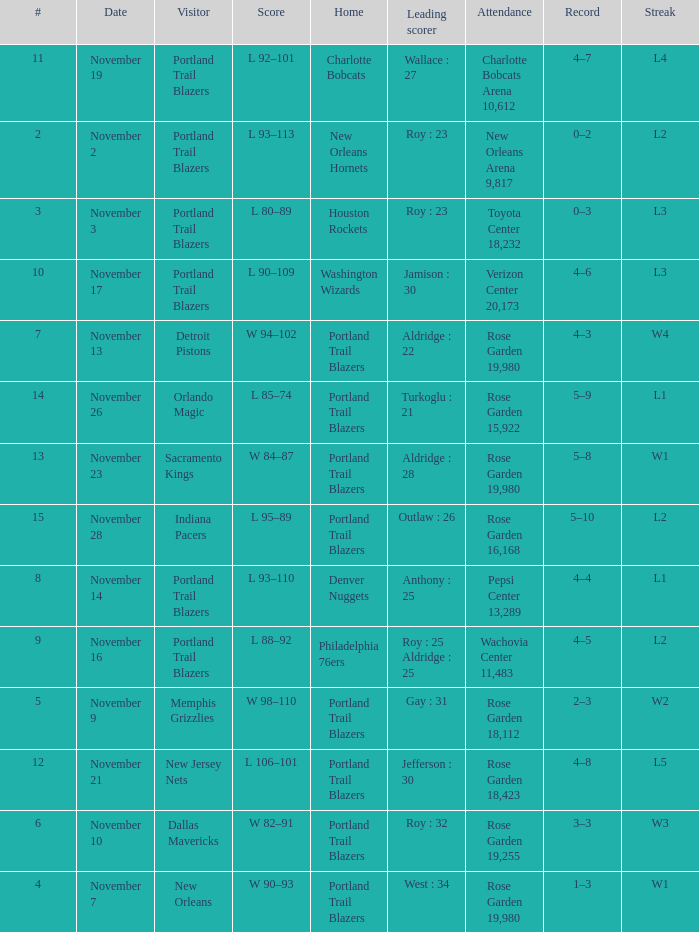 what's the attendance where score is l 92–101 Charlotte Bobcats Arena 10,612. Write the full table. {'header': ['#', 'Date', 'Visitor', 'Score', 'Home', 'Leading scorer', 'Attendance', 'Record', 'Streak'], 'rows': [['11', 'November 19', 'Portland Trail Blazers', 'L 92–101', 'Charlotte Bobcats', 'Wallace : 27', 'Charlotte Bobcats Arena 10,612', '4–7', 'L4'], ['2', 'November 2', 'Portland Trail Blazers', 'L 93–113', 'New Orleans Hornets', 'Roy : 23', 'New Orleans Arena 9,817', '0–2', 'L2'], ['3', 'November 3', 'Portland Trail Blazers', 'L 80–89', 'Houston Rockets', 'Roy : 23', 'Toyota Center 18,232', '0–3', 'L3'], ['10', 'November 17', 'Portland Trail Blazers', 'L 90–109', 'Washington Wizards', 'Jamison : 30', 'Verizon Center 20,173', '4–6', 'L3'], ['7', 'November 13', 'Detroit Pistons', 'W 94–102', 'Portland Trail Blazers', 'Aldridge : 22', 'Rose Garden 19,980', '4–3', 'W4'], ['14', 'November 26', 'Orlando Magic', 'L 85–74', 'Portland Trail Blazers', 'Turkoglu : 21', 'Rose Garden 15,922', '5–9', 'L1'], ['13', 'November 23', 'Sacramento Kings', 'W 84–87', 'Portland Trail Blazers', 'Aldridge : 28', 'Rose Garden 19,980', '5–8', 'W1'], ['15', 'November 28', 'Indiana Pacers', 'L 95–89', 'Portland Trail Blazers', 'Outlaw : 26', 'Rose Garden 16,168', '5–10', 'L2'], ['8', 'November 14', 'Portland Trail Blazers', 'L 93–110', 'Denver Nuggets', 'Anthony : 25', 'Pepsi Center 13,289', '4–4', 'L1'], ['9', 'November 16', 'Portland Trail Blazers', 'L 88–92', 'Philadelphia 76ers', 'Roy : 25 Aldridge : 25', 'Wachovia Center 11,483', '4–5', 'L2'], ['5', 'November 9', 'Memphis Grizzlies', 'W 98–110', 'Portland Trail Blazers', 'Gay : 31', 'Rose Garden 18,112', '2–3', 'W2'], ['12', 'November 21', 'New Jersey Nets', 'L 106–101', 'Portland Trail Blazers', 'Jefferson : 30', 'Rose Garden 18,423', '4–8', 'L5'], ['6', 'November 10', 'Dallas Mavericks', 'W 82–91', 'Portland Trail Blazers', 'Roy : 32', 'Rose Garden 19,255', '3–3', 'W3'], ['4', 'November 7', 'New Orleans', 'W 90–93', 'Portland Trail Blazers', 'West : 34', 'Rose Garden 19,980', '1–3', 'W1']]} 